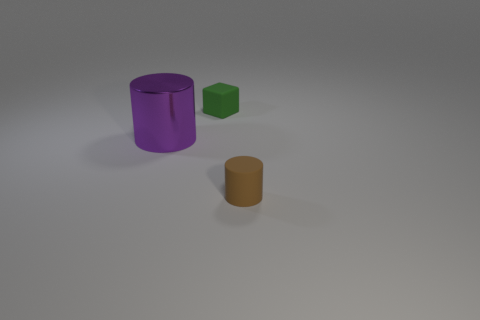Subtract all purple cylinders. How many cylinders are left? 1 Add 1 small brown matte things. How many objects exist? 4 Subtract all cyan blocks. Subtract all blue cylinders. How many blocks are left? 1 Subtract all cylinders. How many objects are left? 1 Subtract all yellow spheres. How many brown cubes are left? 0 Subtract all large things. Subtract all tiny brown matte things. How many objects are left? 1 Add 2 big metallic cylinders. How many big metallic cylinders are left? 3 Add 3 gray blocks. How many gray blocks exist? 3 Subtract 0 blue cylinders. How many objects are left? 3 